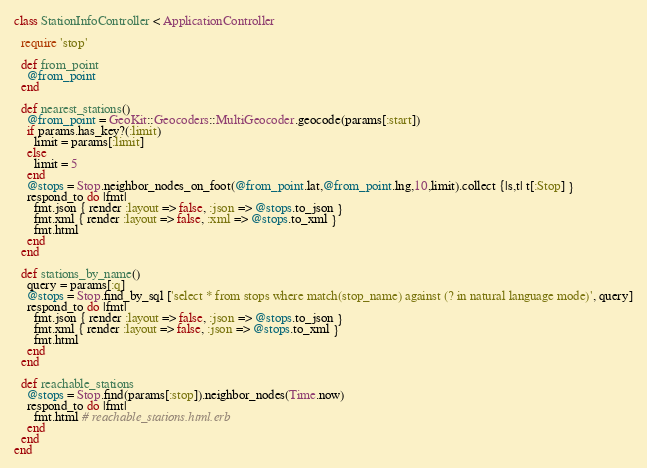<code> <loc_0><loc_0><loc_500><loc_500><_Ruby_>class StationInfoController < ApplicationController

  require 'stop'

  def from_point
    @from_point
  end

  def nearest_stations()
    @from_point = GeoKit::Geocoders::MultiGeocoder.geocode(params[:start])
    if params.has_key?(:limit) 
      limit = params[:limit] 
    else
      limit = 5
    end
    @stops = Stop.neighbor_nodes_on_foot(@from_point.lat,@from_point.lng,10,limit).collect {|s,t| t[:Stop] }
    respond_to do |fmt|
      fmt.json { render :layout => false, :json => @stops.to_json }
      fmt.xml { render :layout => false, :xml => @stops.to_xml }
      fmt.html
    end
  end

  def stations_by_name()
    query = params[:q]
    @stops = Stop.find_by_sql ['select * from stops where match(stop_name) against (? in natural language mode)', query]
    respond_to do |fmt|
      fmt.json { render :layout => false, :json => @stops.to_json }
      fmt.xml { render :layout => false, :json => @stops.to_xml }
      fmt.html
    end
  end

  def reachable_stations
    @stops = Stop.find(params[:stop]).neighbor_nodes(Time.now)
    respond_to do |fmt|
      fmt.html # reachable_stations.html.erb
    end
  end
end
</code> 